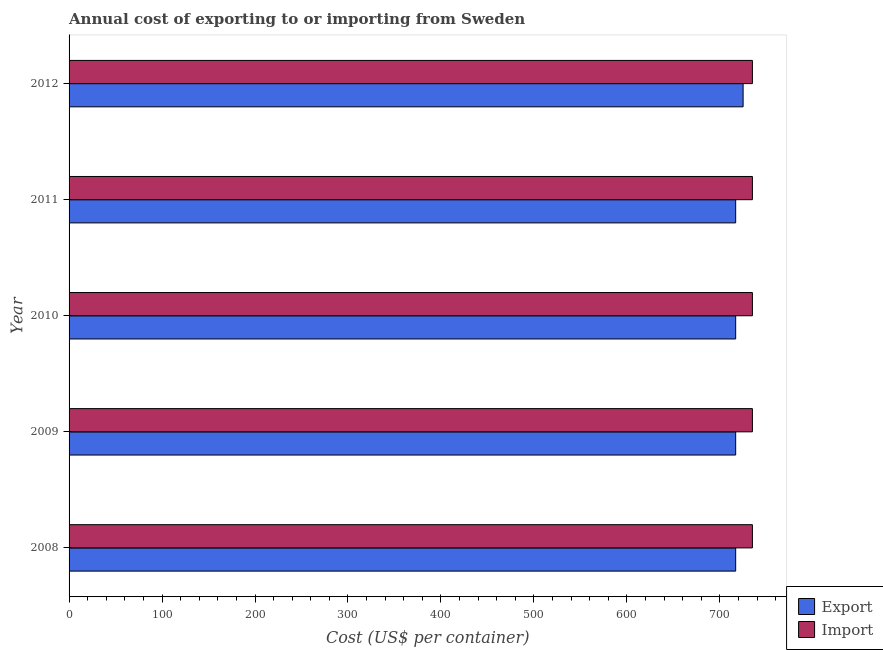How many different coloured bars are there?
Make the answer very short. 2. Are the number of bars on each tick of the Y-axis equal?
Make the answer very short. Yes. What is the label of the 2nd group of bars from the top?
Your answer should be compact. 2011. What is the export cost in 2009?
Offer a very short reply. 717. Across all years, what is the maximum import cost?
Give a very brief answer. 735. Across all years, what is the minimum import cost?
Offer a terse response. 735. In which year was the export cost maximum?
Provide a short and direct response. 2012. What is the total export cost in the graph?
Your response must be concise. 3593. What is the difference between the export cost in 2011 and that in 2012?
Make the answer very short. -8. What is the difference between the import cost in 2011 and the export cost in 2008?
Give a very brief answer. 18. What is the average import cost per year?
Ensure brevity in your answer.  735. In the year 2011, what is the difference between the export cost and import cost?
Provide a succinct answer. -18. In how many years, is the import cost greater than 600 US$?
Keep it short and to the point. 5. Is the difference between the export cost in 2009 and 2012 greater than the difference between the import cost in 2009 and 2012?
Offer a very short reply. No. What is the difference between the highest and the second highest export cost?
Your answer should be very brief. 8. What is the difference between the highest and the lowest export cost?
Make the answer very short. 8. What does the 2nd bar from the top in 2008 represents?
Offer a terse response. Export. What does the 1st bar from the bottom in 2012 represents?
Your answer should be compact. Export. How many bars are there?
Your answer should be very brief. 10. How many years are there in the graph?
Give a very brief answer. 5. What is the difference between two consecutive major ticks on the X-axis?
Keep it short and to the point. 100. Are the values on the major ticks of X-axis written in scientific E-notation?
Your response must be concise. No. Does the graph contain any zero values?
Offer a terse response. No. How are the legend labels stacked?
Give a very brief answer. Vertical. What is the title of the graph?
Your answer should be very brief. Annual cost of exporting to or importing from Sweden. What is the label or title of the X-axis?
Your answer should be very brief. Cost (US$ per container). What is the Cost (US$ per container) in Export in 2008?
Keep it short and to the point. 717. What is the Cost (US$ per container) of Import in 2008?
Provide a succinct answer. 735. What is the Cost (US$ per container) in Export in 2009?
Your response must be concise. 717. What is the Cost (US$ per container) in Import in 2009?
Your answer should be compact. 735. What is the Cost (US$ per container) in Export in 2010?
Provide a succinct answer. 717. What is the Cost (US$ per container) in Import in 2010?
Make the answer very short. 735. What is the Cost (US$ per container) in Export in 2011?
Your response must be concise. 717. What is the Cost (US$ per container) in Import in 2011?
Your answer should be very brief. 735. What is the Cost (US$ per container) of Export in 2012?
Ensure brevity in your answer.  725. What is the Cost (US$ per container) of Import in 2012?
Provide a short and direct response. 735. Across all years, what is the maximum Cost (US$ per container) of Export?
Ensure brevity in your answer.  725. Across all years, what is the maximum Cost (US$ per container) in Import?
Ensure brevity in your answer.  735. Across all years, what is the minimum Cost (US$ per container) of Export?
Your answer should be very brief. 717. Across all years, what is the minimum Cost (US$ per container) of Import?
Your answer should be very brief. 735. What is the total Cost (US$ per container) in Export in the graph?
Keep it short and to the point. 3593. What is the total Cost (US$ per container) in Import in the graph?
Offer a very short reply. 3675. What is the difference between the Cost (US$ per container) of Export in 2008 and that in 2009?
Provide a short and direct response. 0. What is the difference between the Cost (US$ per container) in Import in 2008 and that in 2009?
Ensure brevity in your answer.  0. What is the difference between the Cost (US$ per container) in Export in 2008 and that in 2010?
Offer a terse response. 0. What is the difference between the Cost (US$ per container) in Import in 2008 and that in 2010?
Give a very brief answer. 0. What is the difference between the Cost (US$ per container) of Export in 2008 and that in 2011?
Offer a very short reply. 0. What is the difference between the Cost (US$ per container) in Import in 2008 and that in 2011?
Give a very brief answer. 0. What is the difference between the Cost (US$ per container) of Export in 2008 and that in 2012?
Provide a short and direct response. -8. What is the difference between the Cost (US$ per container) of Export in 2009 and that in 2010?
Give a very brief answer. 0. What is the difference between the Cost (US$ per container) of Export in 2009 and that in 2011?
Provide a short and direct response. 0. What is the difference between the Cost (US$ per container) in Export in 2009 and that in 2012?
Provide a succinct answer. -8. What is the difference between the Cost (US$ per container) of Import in 2010 and that in 2012?
Your answer should be compact. 0. What is the difference between the Cost (US$ per container) in Export in 2011 and that in 2012?
Your answer should be compact. -8. What is the difference between the Cost (US$ per container) of Export in 2008 and the Cost (US$ per container) of Import in 2009?
Your response must be concise. -18. What is the difference between the Cost (US$ per container) in Export in 2008 and the Cost (US$ per container) in Import in 2010?
Your answer should be very brief. -18. What is the difference between the Cost (US$ per container) in Export in 2009 and the Cost (US$ per container) in Import in 2010?
Give a very brief answer. -18. What is the difference between the Cost (US$ per container) in Export in 2009 and the Cost (US$ per container) in Import in 2011?
Ensure brevity in your answer.  -18. What is the difference between the Cost (US$ per container) in Export in 2010 and the Cost (US$ per container) in Import in 2011?
Keep it short and to the point. -18. What is the difference between the Cost (US$ per container) in Export in 2010 and the Cost (US$ per container) in Import in 2012?
Your answer should be very brief. -18. What is the average Cost (US$ per container) in Export per year?
Provide a succinct answer. 718.6. What is the average Cost (US$ per container) of Import per year?
Offer a terse response. 735. In the year 2008, what is the difference between the Cost (US$ per container) in Export and Cost (US$ per container) in Import?
Offer a terse response. -18. In the year 2009, what is the difference between the Cost (US$ per container) in Export and Cost (US$ per container) in Import?
Your response must be concise. -18. What is the ratio of the Cost (US$ per container) in Export in 2008 to that in 2009?
Offer a terse response. 1. What is the ratio of the Cost (US$ per container) of Export in 2008 to that in 2010?
Offer a very short reply. 1. What is the ratio of the Cost (US$ per container) of Export in 2008 to that in 2011?
Your response must be concise. 1. What is the ratio of the Cost (US$ per container) of Export in 2009 to that in 2010?
Ensure brevity in your answer.  1. What is the ratio of the Cost (US$ per container) in Import in 2009 to that in 2010?
Make the answer very short. 1. What is the ratio of the Cost (US$ per container) in Export in 2009 to that in 2011?
Your response must be concise. 1. What is the ratio of the Cost (US$ per container) of Export in 2010 to that in 2011?
Your response must be concise. 1. What is the ratio of the Cost (US$ per container) in Import in 2010 to that in 2011?
Provide a succinct answer. 1. What is the ratio of the Cost (US$ per container) in Import in 2011 to that in 2012?
Make the answer very short. 1. What is the difference between the highest and the lowest Cost (US$ per container) of Export?
Give a very brief answer. 8. What is the difference between the highest and the lowest Cost (US$ per container) in Import?
Make the answer very short. 0. 